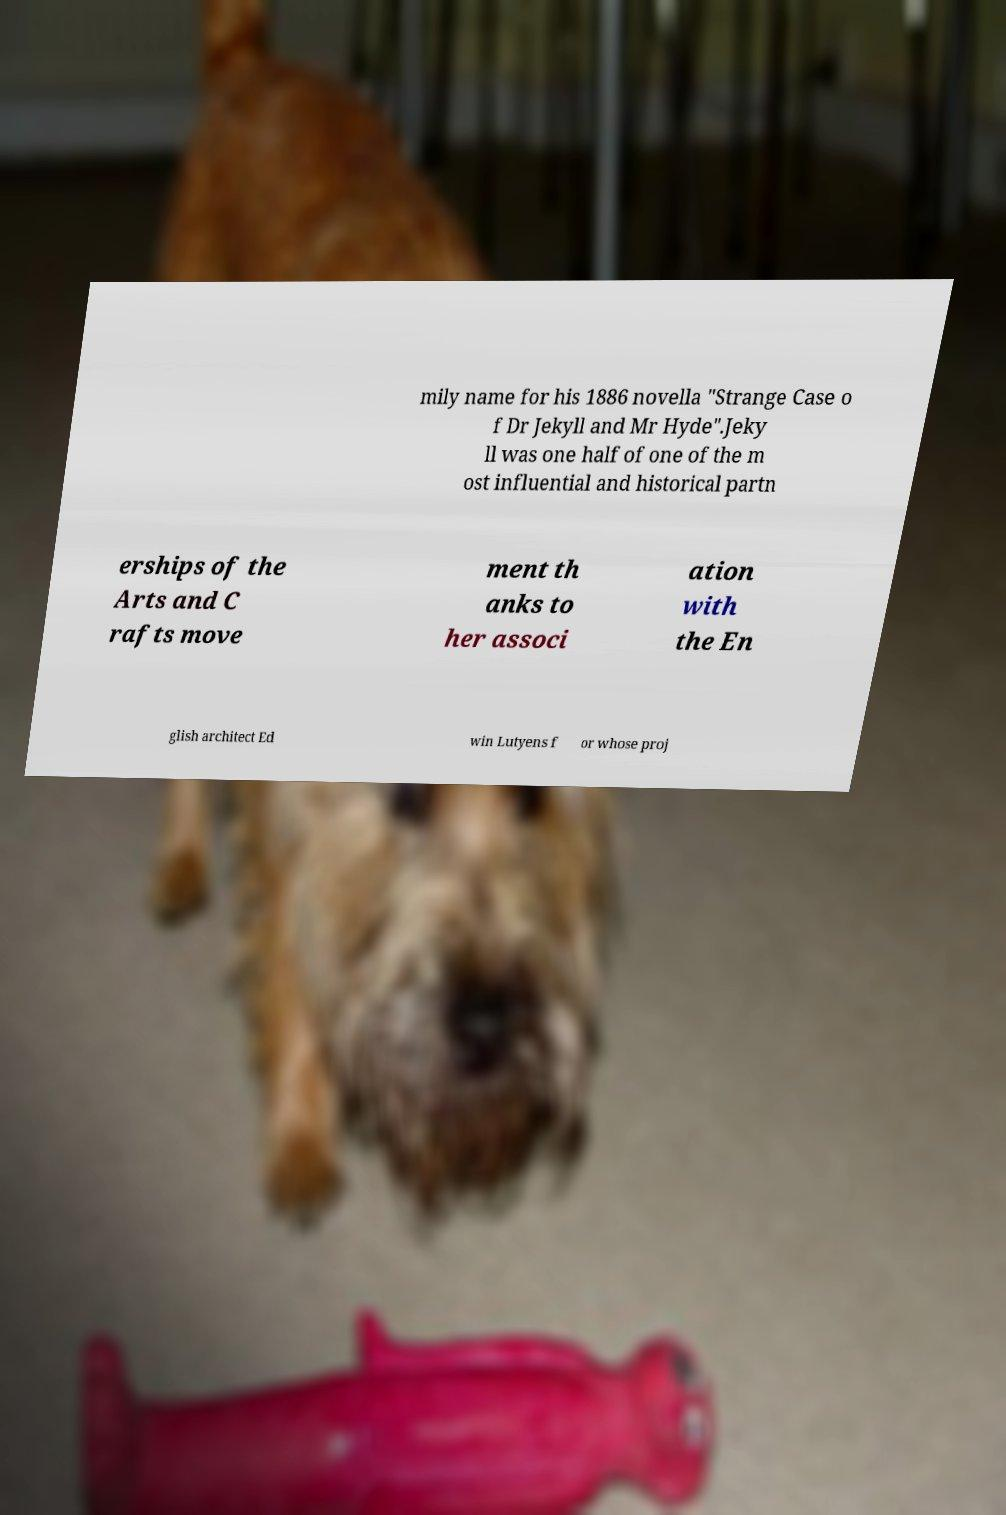Could you extract and type out the text from this image? mily name for his 1886 novella "Strange Case o f Dr Jekyll and Mr Hyde".Jeky ll was one half of one of the m ost influential and historical partn erships of the Arts and C rafts move ment th anks to her associ ation with the En glish architect Ed win Lutyens f or whose proj 